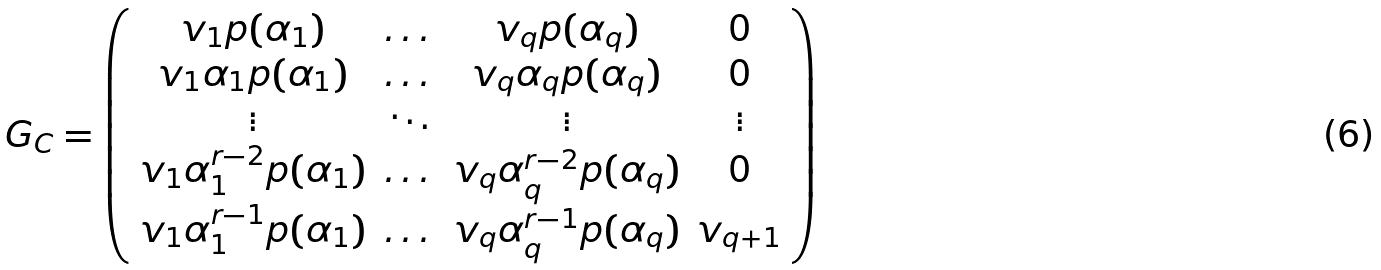<formula> <loc_0><loc_0><loc_500><loc_500>G _ { C } = { \left ( \begin{array} { c c c c } v _ { 1 } p ( \alpha _ { 1 } ) & \dots & v _ { q } p ( \alpha _ { q } ) & 0 \\ v _ { 1 } \alpha _ { 1 } p ( \alpha _ { 1 } ) & \dots & v _ { q } \alpha _ { q } p ( \alpha _ { q } ) & 0 \\ \vdots & \ddots & \vdots & \vdots \\ v _ { 1 } \alpha _ { 1 } ^ { r - 2 } p ( \alpha _ { 1 } ) & \dots & v _ { q } \alpha _ { q } ^ { r - 2 } p ( \alpha _ { q } ) & 0 \\ v _ { 1 } \alpha _ { 1 } ^ { r - 1 } p ( \alpha _ { 1 } ) & \dots & v _ { q } \alpha _ { q } ^ { r - 1 } p ( \alpha _ { q } ) & v _ { q + 1 } \\ \end{array} \right ) }</formula> 